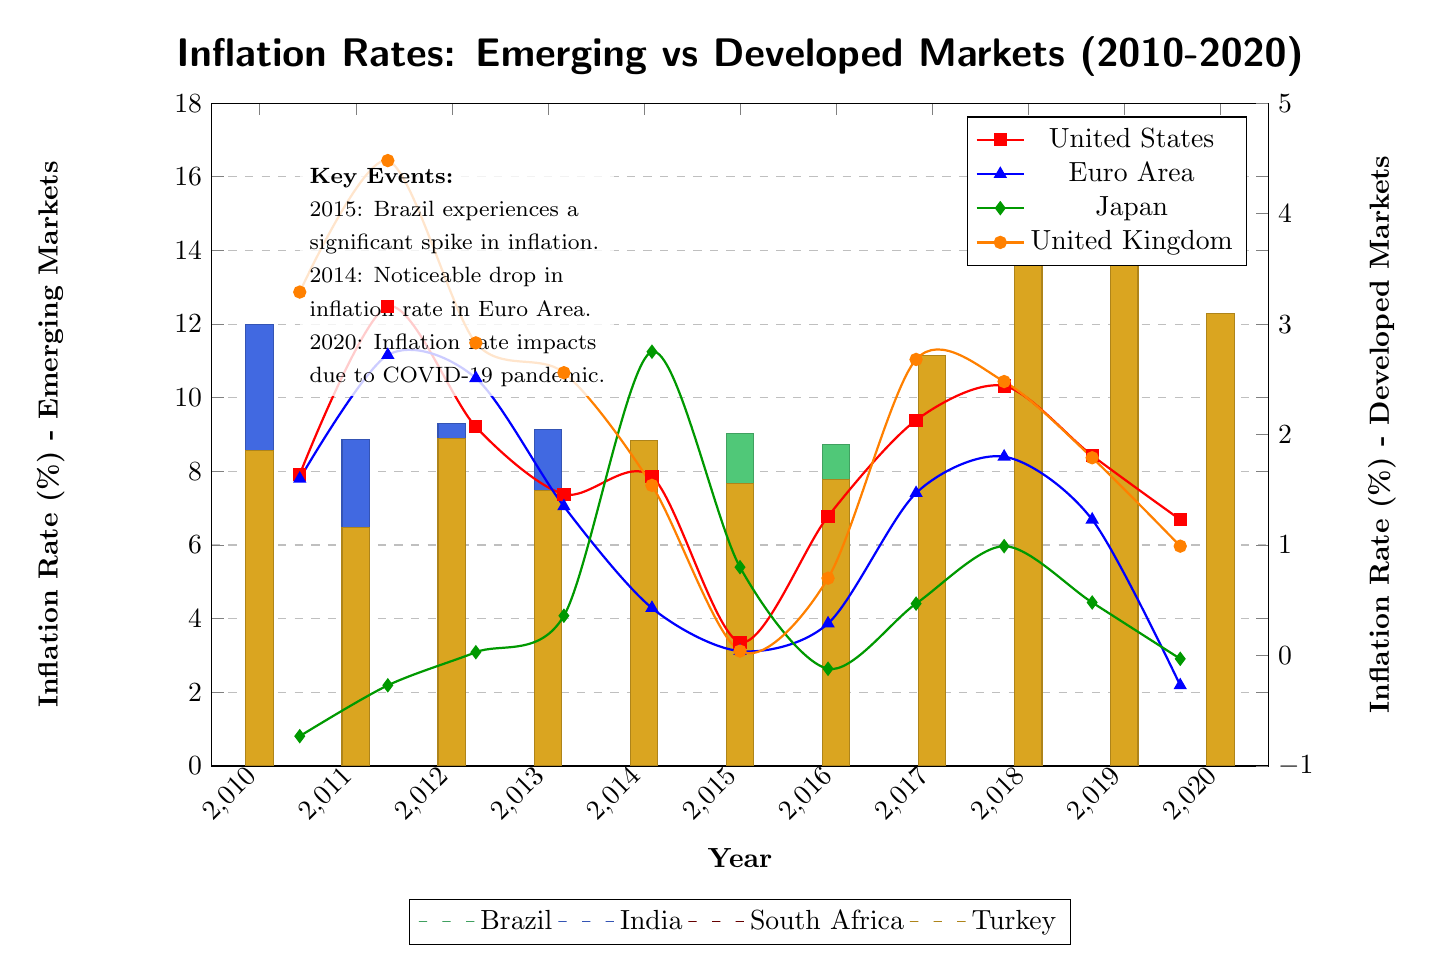What was the highest inflation rate for Brazil in the given years? The highest inflation rate for Brazil can be found by scanning the bar for Brazil. The peak is at year 2015, where it reaches a value of 9.03 percent.
Answer: 9.03 Which country experienced the lowest inflation rate in 2020? In 2020, the inflation rates are represented by bars and a line. By comparing the values, Japan has the lowest inflation rate at -0.03 percent.
Answer: -0.03 What is the trend of inflation rates for the Euro Area from 2010 to 2020? The inflation rates for the Euro Area can be observed on the line chart. In 2010, it starts at 1.60 percent, experiences a gradual decline from 2014 to 2015, and fluctuates slightly until falling to -0.27 percent by 2020. This indicates a declining trend overall.
Answer: Declining How does the inflation rate in the emerging market Turkey in 2018 compare to that in the developed market United States? In 2018, Turkey’s inflation rate is observed at 16.33 percent while the United States has an inflation rate of 2.44 percent. Comparing these, Turkey significantly exceeds the United States by about 13.89 percentage points.
Answer: 13.89 What year saw a significant spike in inflation for Turkey compared to other years? By examining the bar for Turkey, the year 2018 clearly shows a notable spike at 16.33 percent, which is higher than most other years.
Answer: 2018 In which year did India have an inflation rate below 4 percent? Looking at the bar for India, the only year where the inflation rate falls below 4 percent is 2017, where it reaches 3.33 percent.
Answer: 2017 How do the inflation rates in emerging markets compare to developed markets in 2020? In 2020, the inflation rates show emerging markets have higher values with Brazil at 3.21 percent and India at 6.62 percent, while developed markets like the United States and Euro Area significantly lower at 1.23 and -0.27 respectively. This indicates emerging markets generally maintained higher inflation rates in comparison.
Answer: Emerging markets higher Which emerging market saw a gradual decline in inflation from 2015 to 2020? Observing the data for South Africa from the bar chart, it shows a decline from 4.62 percent in 2015 down to 3.20 percent in 2020, indicating a consistent decrease over those years.
Answer: South Africa 